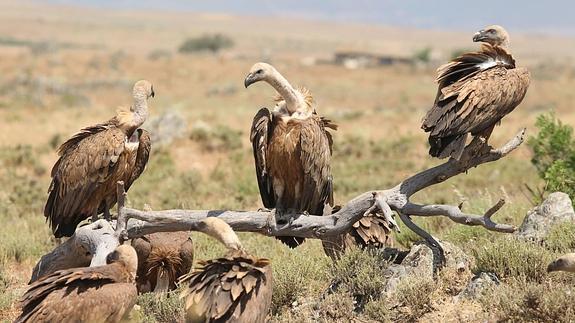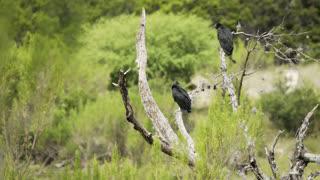The first image is the image on the left, the second image is the image on the right. Evaluate the accuracy of this statement regarding the images: "The bird in the image on the left has its wings spread wide.". Is it true? Answer yes or no. No. The first image is the image on the left, the second image is the image on the right. For the images shown, is this caption "An image contains just one bird, perched with outspread wings on an object that is not a tree branch." true? Answer yes or no. No. 